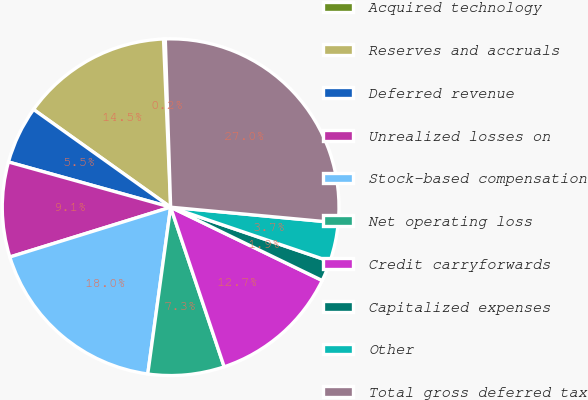Convert chart. <chart><loc_0><loc_0><loc_500><loc_500><pie_chart><fcel>Acquired technology<fcel>Reserves and accruals<fcel>Deferred revenue<fcel>Unrealized losses on<fcel>Stock-based compensation<fcel>Net operating loss<fcel>Credit carryforwards<fcel>Capitalized expenses<fcel>Other<fcel>Total gross deferred tax<nl><fcel>0.17%<fcel>14.47%<fcel>5.53%<fcel>9.11%<fcel>18.05%<fcel>7.32%<fcel>12.68%<fcel>1.95%<fcel>3.74%<fcel>26.99%<nl></chart> 